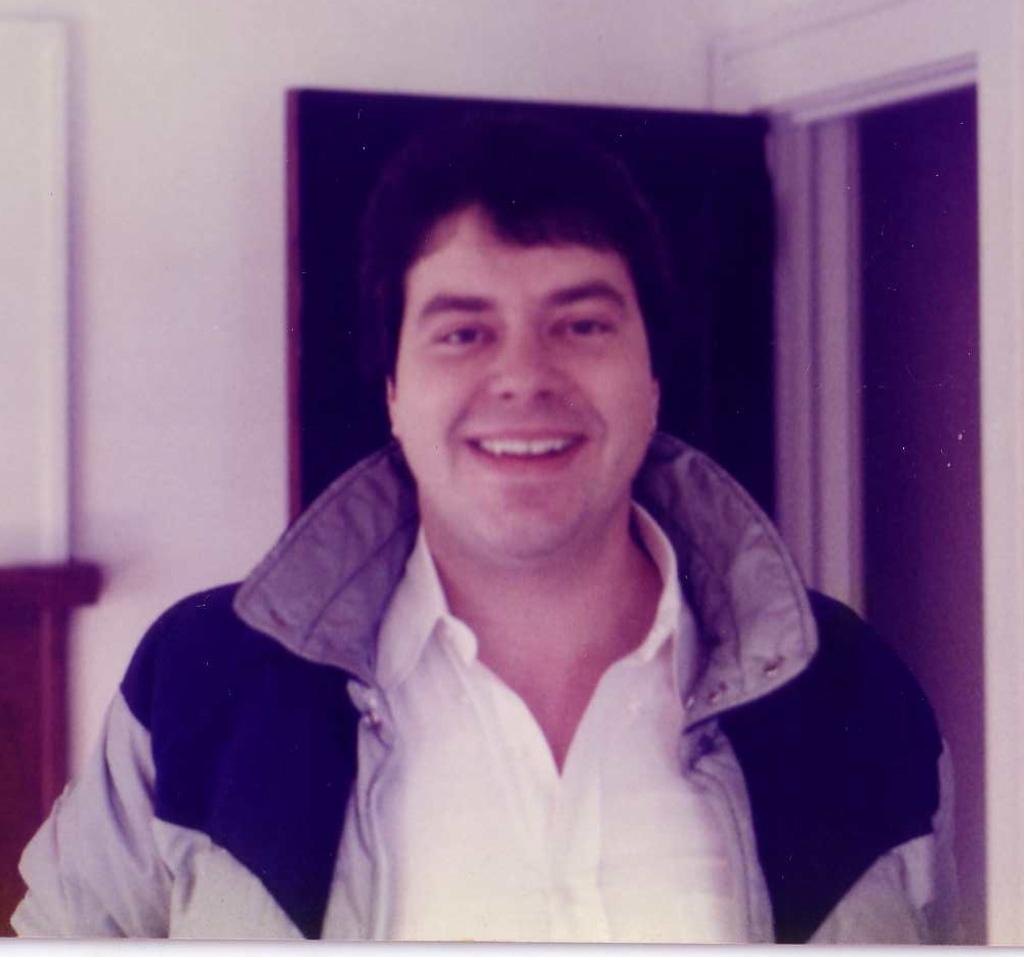Who is present in the image? There is a man in the image. What is the man doing in the image? The man is standing in the image. What expression does the man have in the image? The man is smiling in the image. What can be seen behind the man in the image? There is a wall behind the man in the image. What feature of the wall is visible in the image? There is a door in the wall in the image. Can you see the man's toes in the image? There is no mention of the man's toes in the image, so it cannot be seen. 